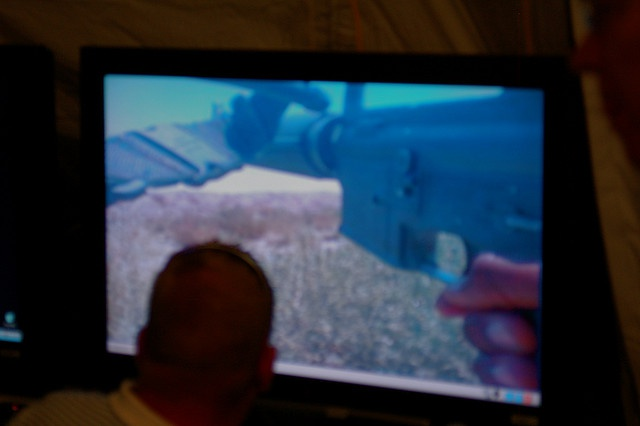Describe the objects in this image and their specific colors. I can see tv in black, blue, gray, and darkgray tones and people in black, maroon, and gray tones in this image. 